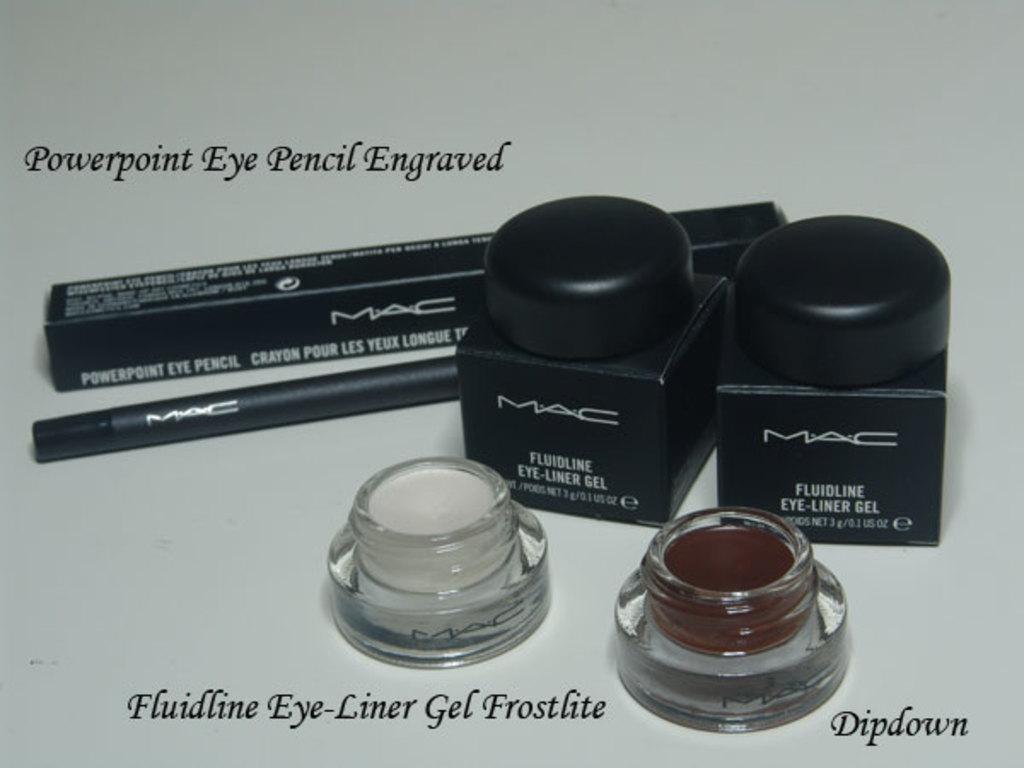<image>
Render a clear and concise summary of the photo. Various make up products on a table like Eye-liner and Dipdown. 